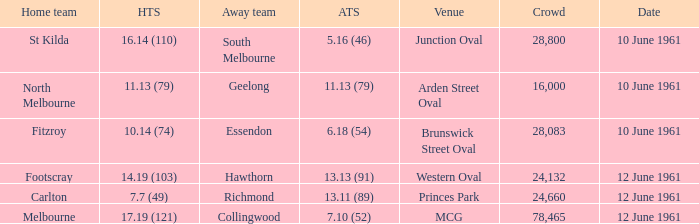Which venue has a crowd over 16,000 and a home team score of 7.7 (49)? Princes Park. 